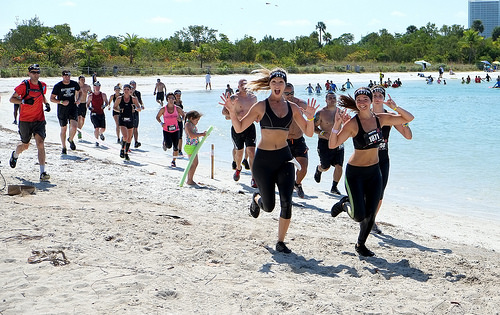<image>
Is there a lady in the water? No. The lady is not contained within the water. These objects have a different spatial relationship. 